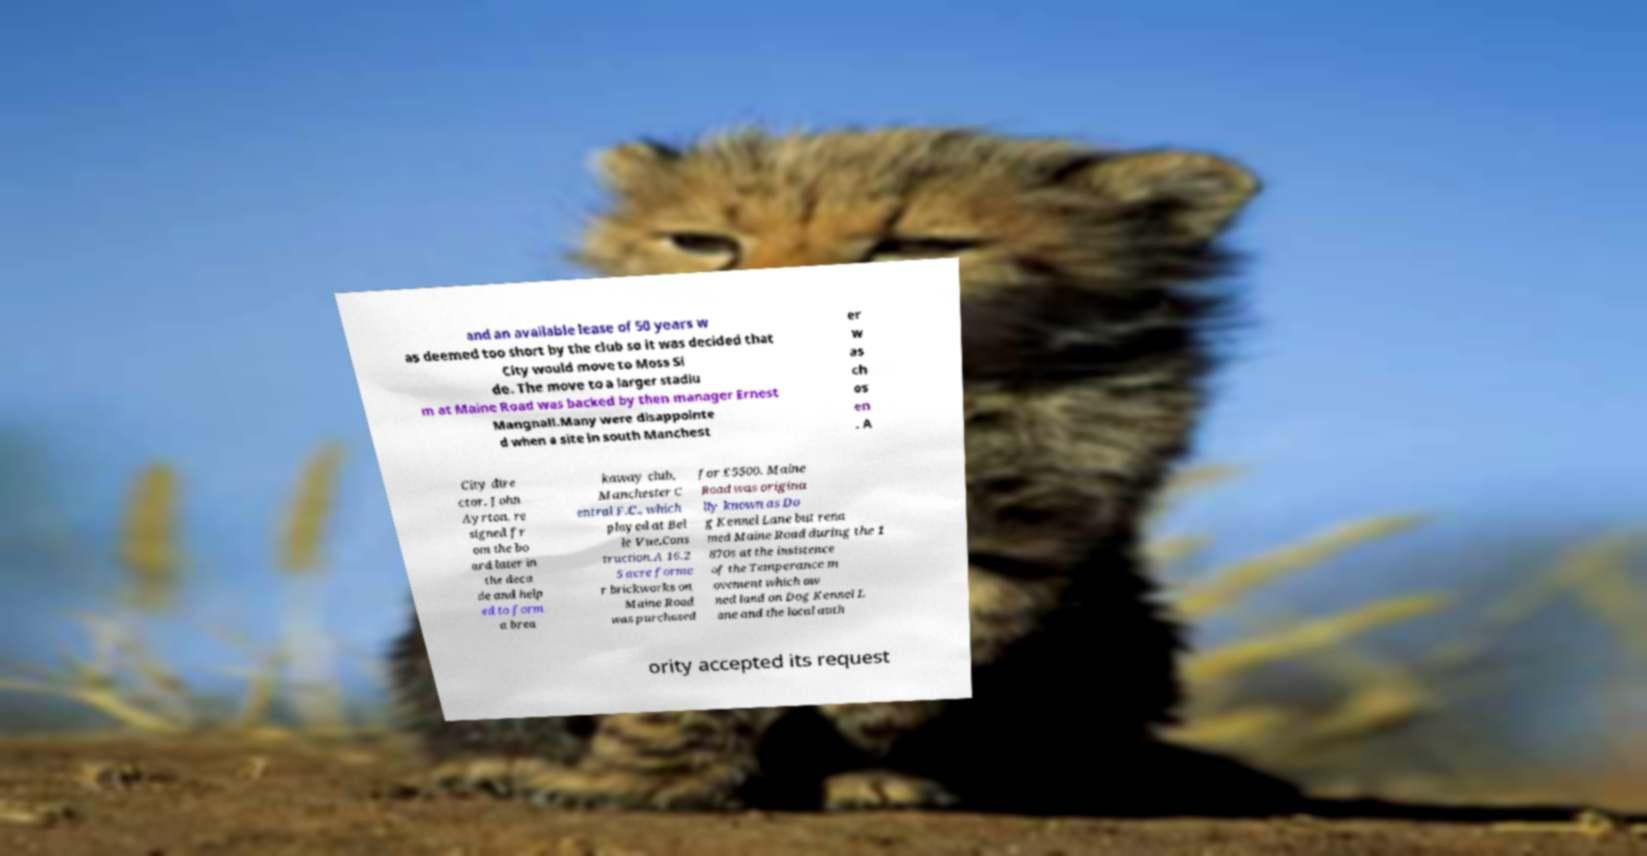Please read and relay the text visible in this image. What does it say? and an available lease of 50 years w as deemed too short by the club so it was decided that City would move to Moss Si de. The move to a larger stadiu m at Maine Road was backed by then manager Ernest Mangnall.Many were disappointe d when a site in south Manchest er w as ch os en . A City dire ctor, John Ayrton, re signed fr om the bo ard later in the deca de and help ed to form a brea kaway club, Manchester C entral F.C., which played at Bel le Vue.Cons truction.A 16.2 5 acre forme r brickworks on Maine Road was purchased for £5500. Maine Road was origina lly known as Do g Kennel Lane but rena med Maine Road during the 1 870s at the insistence of the Temperance m ovement which ow ned land on Dog Kennel L ane and the local auth ority accepted its request 